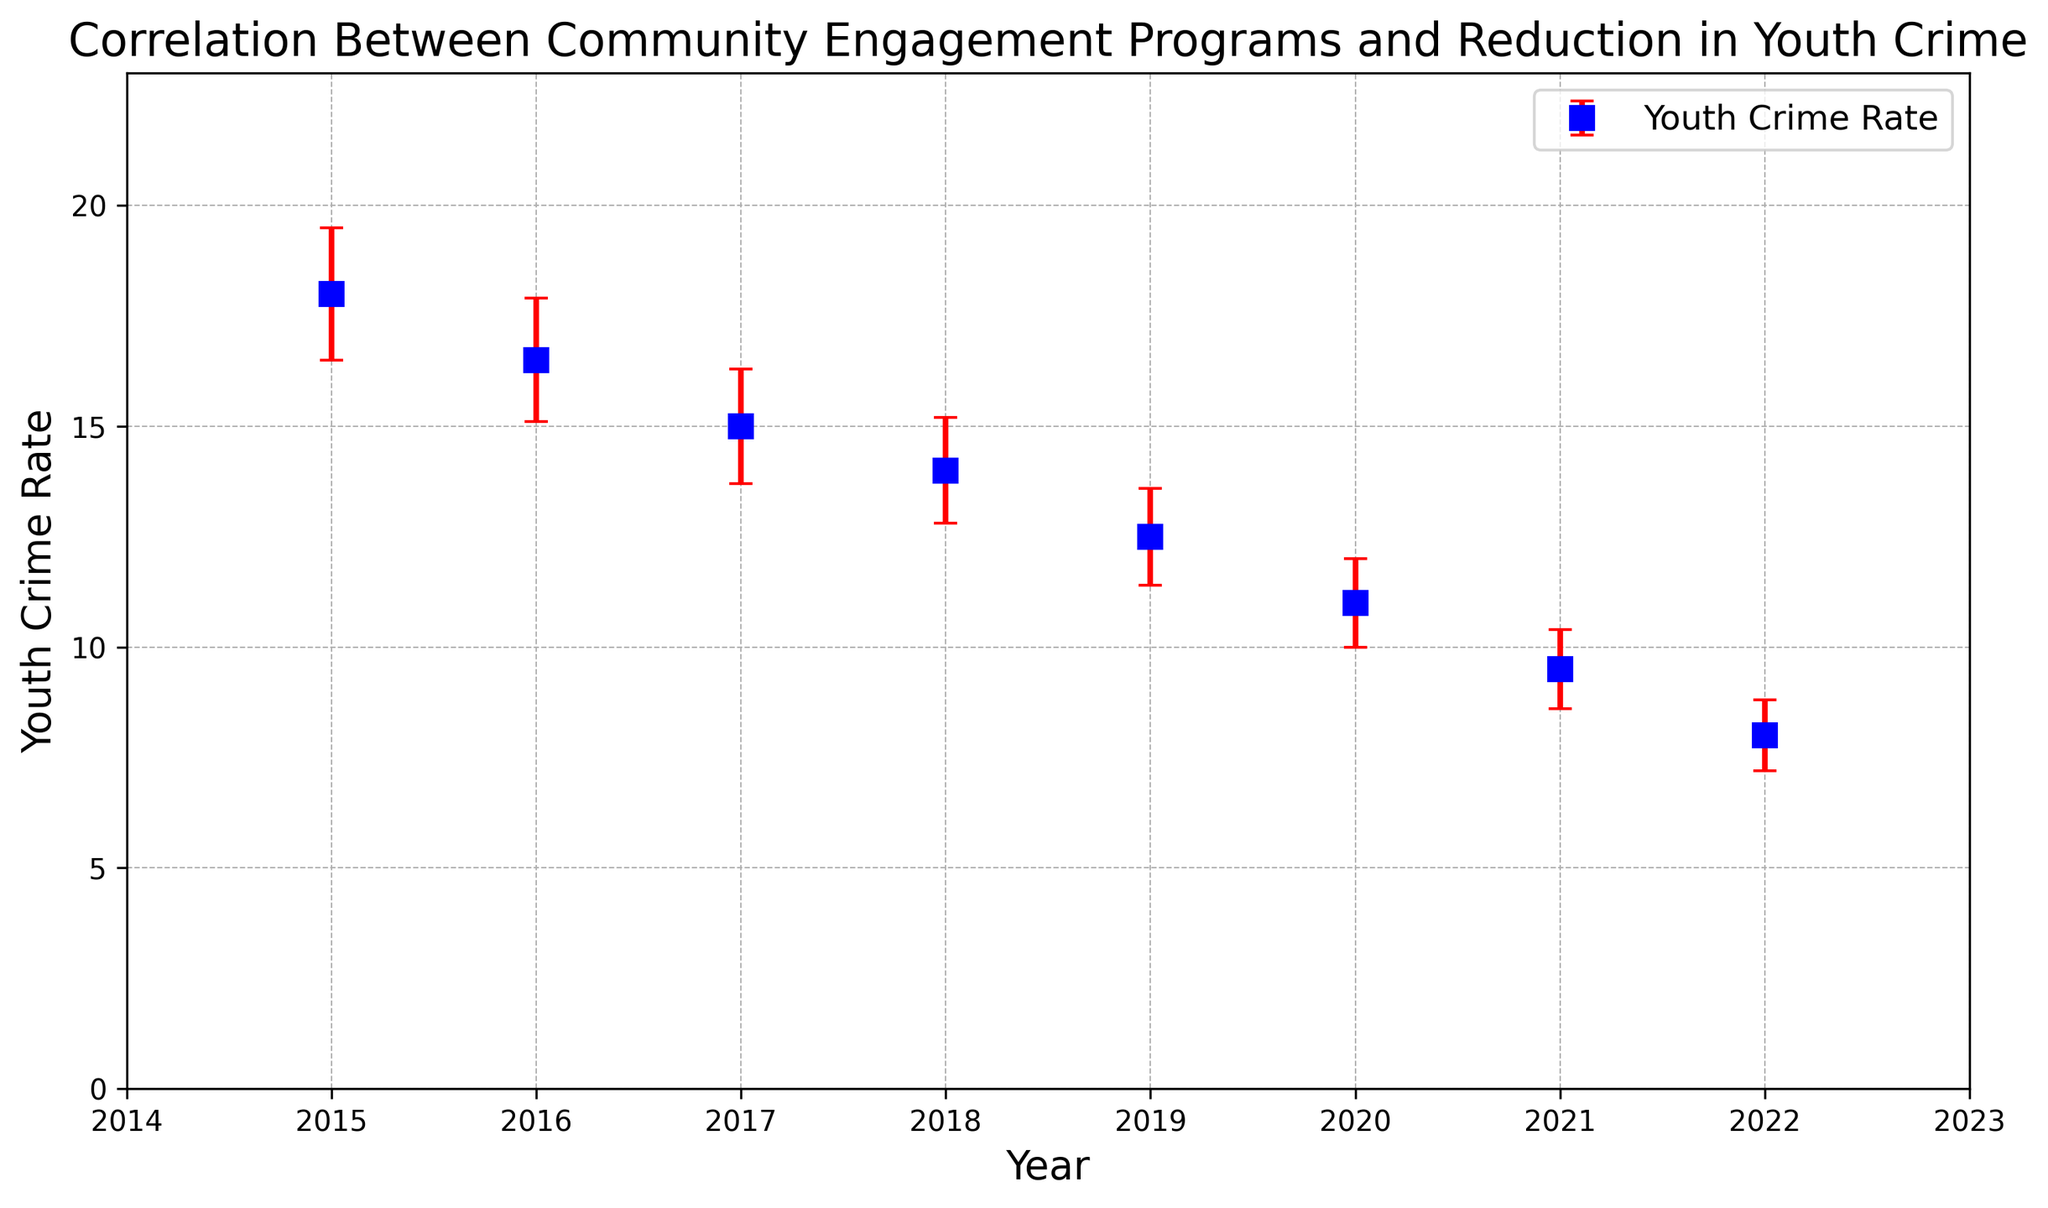What trend is observed in the youth crime rate from 2015 to 2022? By examining the figure, we can see that the youth crime rate consistently decreases from 18 in 2015 to 8 in 2022. This shows a downward trend in youth crime rates over the years.
Answer: Decreasing trend How does the error margin for youth crime rate change from 2015 to 2022? The error margin decreases each year, starting at 1.5 in 2015 and reducing to 0.8 in 2022. This indicates an increasing accuracy in the reported crime rates over time.
Answer: Decreasing error margin What is the difference in youth crime rate between the years 2015 and 2022? The youth crime rate in 2015 is 18 and in 2022 is 8. To find the difference, we subtract the latter from the former: 18 - 8 = 10.
Answer: 10 What year showed the lowest youth crime rate? By observing the error bars and data points, the year 2022 has the lowest youth crime rate, marked at 8.
Answer: 2022 Which year exhibited the highest community engagement index? According to the figure, the highest community engagement index is in the year 2022 with an index value of 89.
Answer: 2022 How are the community engagement index and youth crime rate correlated over the years? From the figure, as the community engagement index increases from 72 in 2015 to 89 in 2022, the youth crime rate decreases from 18 to 8, suggesting a negative correlation between the two variables.
Answer: Negative correlation By how much did the youth crime rate reduce from 2018 to 2020? The youth crime rate in 2018 is 14, and it decreased to 11 in 2020. The reduction can be calculated as 14 - 11 = 3.
Answer: 3 Is the youth crime rate in 2021 closer to the rate in 2015 or 2022? The youth crime rate in 2021 is 9.5. The difference from 2015 (18) is 8.5, and from 2022 (8) is 1.5. Since 1.5 is less than 8.5, the 2021 rate is closer to the 2022 rate.
Answer: Closer to 2022 rate What were the community engagement index and youth crime rate in 2019? Referring to the figure, in 2019, the community engagement index was 83 and the youth crime rate was 12.5.
Answer: Community engagement index: 83, Youth crime rate: 12.5 Which year had the smallest error margin for youth crime rate, and what was it? Observing the error bars, the smallest error margin is in 2022 with a value of 0.8.
Answer: 2022, 0.8 